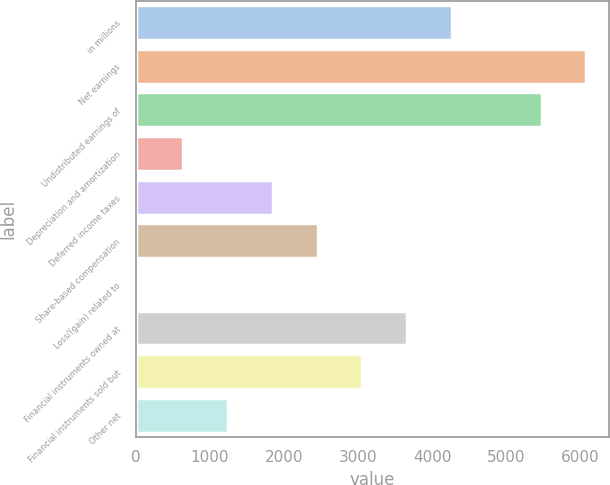Convert chart to OTSL. <chart><loc_0><loc_0><loc_500><loc_500><bar_chart><fcel>in millions<fcel>Net earnings<fcel>Undistributed earnings of<fcel>Depreciation and amortization<fcel>Deferred income taxes<fcel>Share-based compensation<fcel>Loss/(gain) related to<fcel>Financial instruments owned at<fcel>Financial instruments sold but<fcel>Other net<nl><fcel>4268.3<fcel>6083<fcel>5478.1<fcel>638.9<fcel>1848.7<fcel>2453.6<fcel>34<fcel>3663.4<fcel>3058.5<fcel>1243.8<nl></chart> 